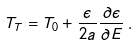Convert formula to latex. <formula><loc_0><loc_0><loc_500><loc_500>T _ { T } = T _ { 0 } + \frac { \epsilon } { 2 a } \frac { \partial \epsilon } { \partial E } \, .</formula> 